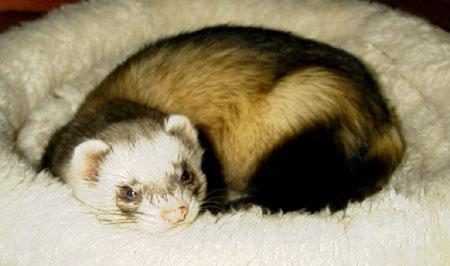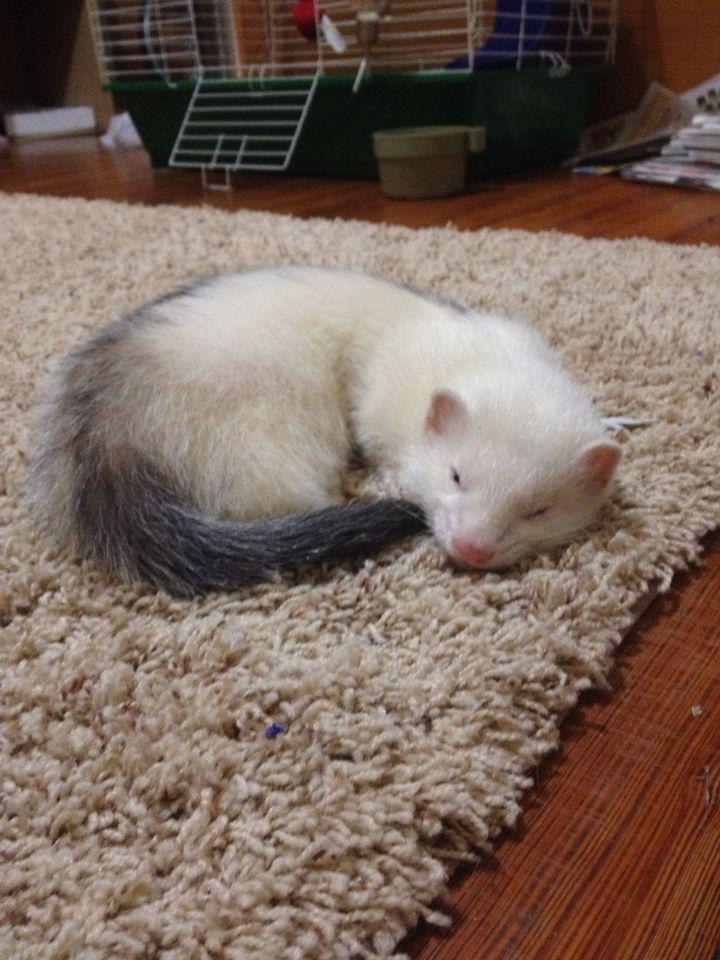The first image is the image on the left, the second image is the image on the right. Assess this claim about the two images: "There are a total of three ferrets.". Correct or not? Answer yes or no. No. 